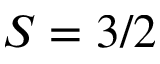Convert formula to latex. <formula><loc_0><loc_0><loc_500><loc_500>S = 3 / 2</formula> 